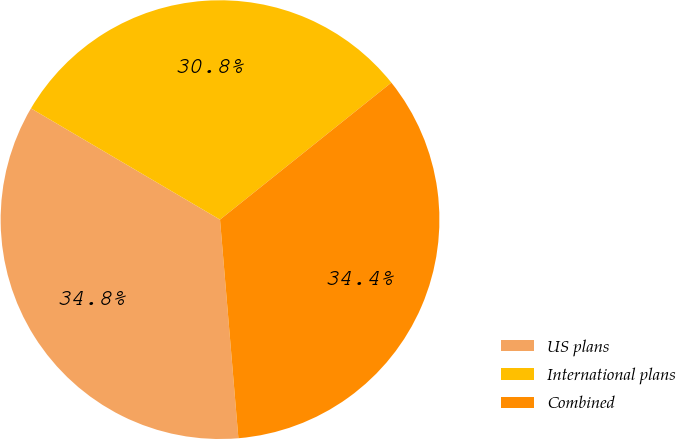Convert chart to OTSL. <chart><loc_0><loc_0><loc_500><loc_500><pie_chart><fcel>US plans<fcel>International plans<fcel>Combined<nl><fcel>34.8%<fcel>30.8%<fcel>34.4%<nl></chart> 